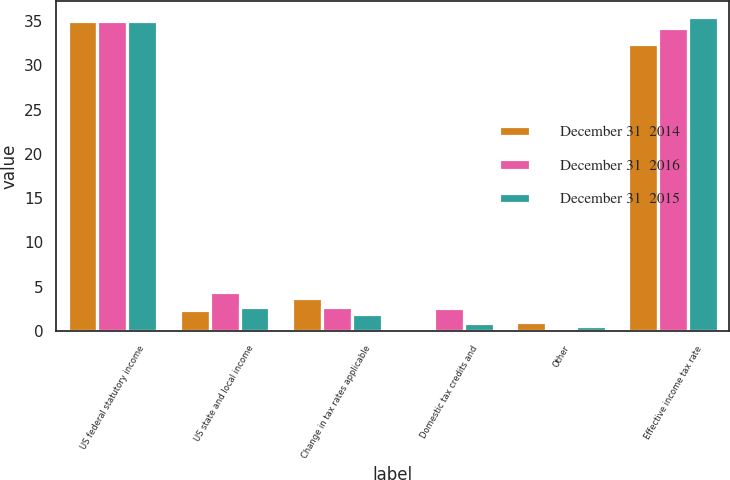Convert chart to OTSL. <chart><loc_0><loc_0><loc_500><loc_500><stacked_bar_chart><ecel><fcel>US federal statutory income<fcel>US state and local income<fcel>Change in tax rates applicable<fcel>Domestic tax credits and<fcel>Other<fcel>Effective income tax rate<nl><fcel>December 31  2014<fcel>35<fcel>2.38<fcel>3.73<fcel>0.26<fcel>0.98<fcel>32.41<nl><fcel>December 31  2016<fcel>35<fcel>4.44<fcel>2.73<fcel>2.62<fcel>0.1<fcel>34.19<nl><fcel>December 31  2015<fcel>35<fcel>2.72<fcel>1.88<fcel>0.86<fcel>0.5<fcel>35.48<nl></chart> 